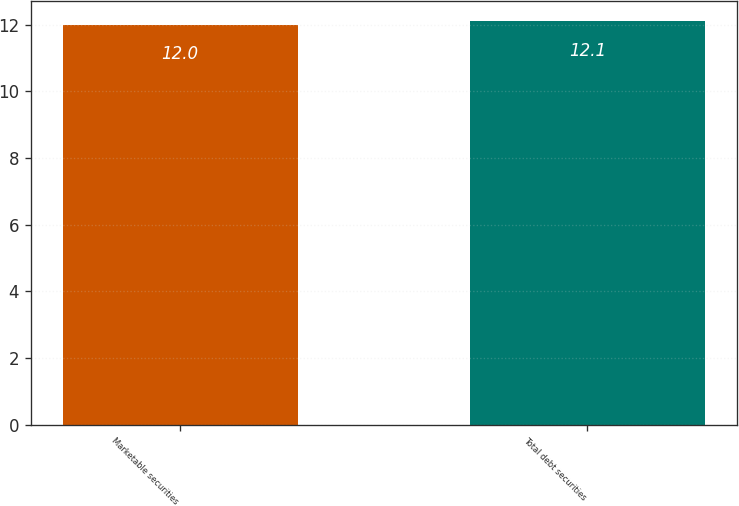Convert chart to OTSL. <chart><loc_0><loc_0><loc_500><loc_500><bar_chart><fcel>Marketable securities<fcel>Total debt securities<nl><fcel>12<fcel>12.1<nl></chart> 